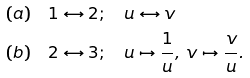Convert formula to latex. <formula><loc_0><loc_0><loc_500><loc_500>( a ) & \quad 1 \leftrightarrow 2 ; \quad u \leftrightarrow v \\ ( b ) & \quad 2 \leftrightarrow 3 ; \quad u \mapsto \frac { 1 } { u } , \, v \mapsto \frac { v } { u } .</formula> 